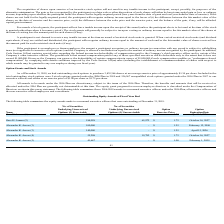According to Protagenic Therapeutics's financial document, How many of Garo H. Armen's options would expire on April 15, 2026?  According to the financial document, 500,000. The relevant text states: "Garo H. Armen (1) 500,000 - $ 1.25 April 15, 2026..." Also, How many of Garo H. Armen's options would expire on October 16, 2027? According to the financial document, 184,028. The relevant text states: "Garo H. Armen (2) 184,028 65,972 $ 1.75 October 16, 2027..." Also, How many of Alexander K. Arrow's options would expire n April 15, 2026? According to the financial document, 140,000. The relevant text states: "Alexander K. Arrow (3) 140,000 - $ 1.25 April 15, 2026..." Also, can you calculate: How many options would expire on April 15, 2026? Based on the calculation: 500,000 + 140,000 , the result is 640000. This is based on the information: "Alexander K. Arrow (3) 140,000 - $ 1.25 April 15, 2026 Garo H. Armen (1) 500,000 - $ 1.25 April 15, 2026..." The key data points involved are: 140,000, 500,000. Also, can you calculate: How many options would expire on October 16, 2027? Based on the calculation: 184,028 + 55,208 , the result is 239236. This is based on the information: "Garo H. Armen (2) 184,028 65,972 $ 1.75 October 16, 2027 Alexander K. Arrow (4) 55,208 19,792 $ 1.75 October 16, 2027..." The key data points involved are: 184,028, 55,208. Also, can you calculate: How many unexercised options does Garo H. Armen have as at December 31, 2019? Based on the calculation: 500,000 + 184,028 , the result is 684028. This is based on the information: "Garo H. Armen (1) 500,000 - $ 1.25 April 15, 2026 Garo H. Armen (2) 184,028 65,972 $ 1.75 October 16, 2027..." The key data points involved are: 184,028, 500,000. 